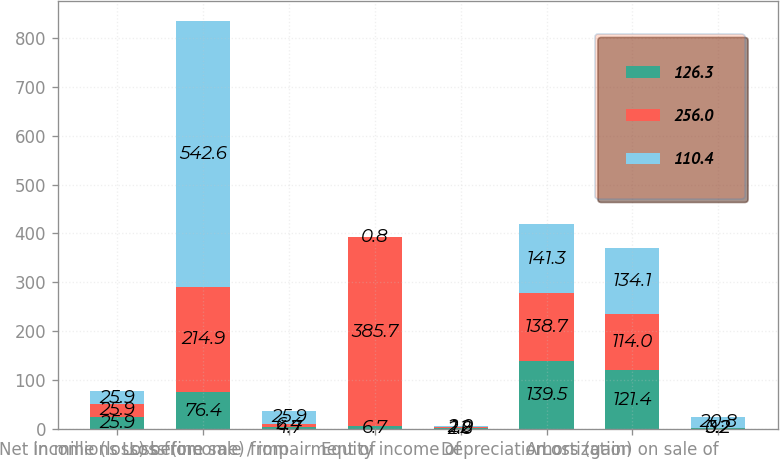<chart> <loc_0><loc_0><loc_500><loc_500><stacked_bar_chart><ecel><fcel>In millions<fcel>Net income (loss) before<fcel>Loss (income) from<fcel>Loss from sale / impairment of<fcel>Equity income of<fcel>Depreciation<fcel>Amortization<fcel>Loss (gain) on sale of<nl><fcel>126.3<fcel>25.9<fcel>76.4<fcel>4.7<fcel>6.7<fcel>2.8<fcel>139.5<fcel>121.4<fcel>3.2<nl><fcel>256<fcel>25.9<fcel>214.9<fcel>6.4<fcel>385.7<fcel>1.2<fcel>138.7<fcel>114<fcel>0.2<nl><fcel>110.4<fcel>25.9<fcel>542.6<fcel>25.9<fcel>0.8<fcel>2<fcel>141.3<fcel>134.1<fcel>20.8<nl></chart> 